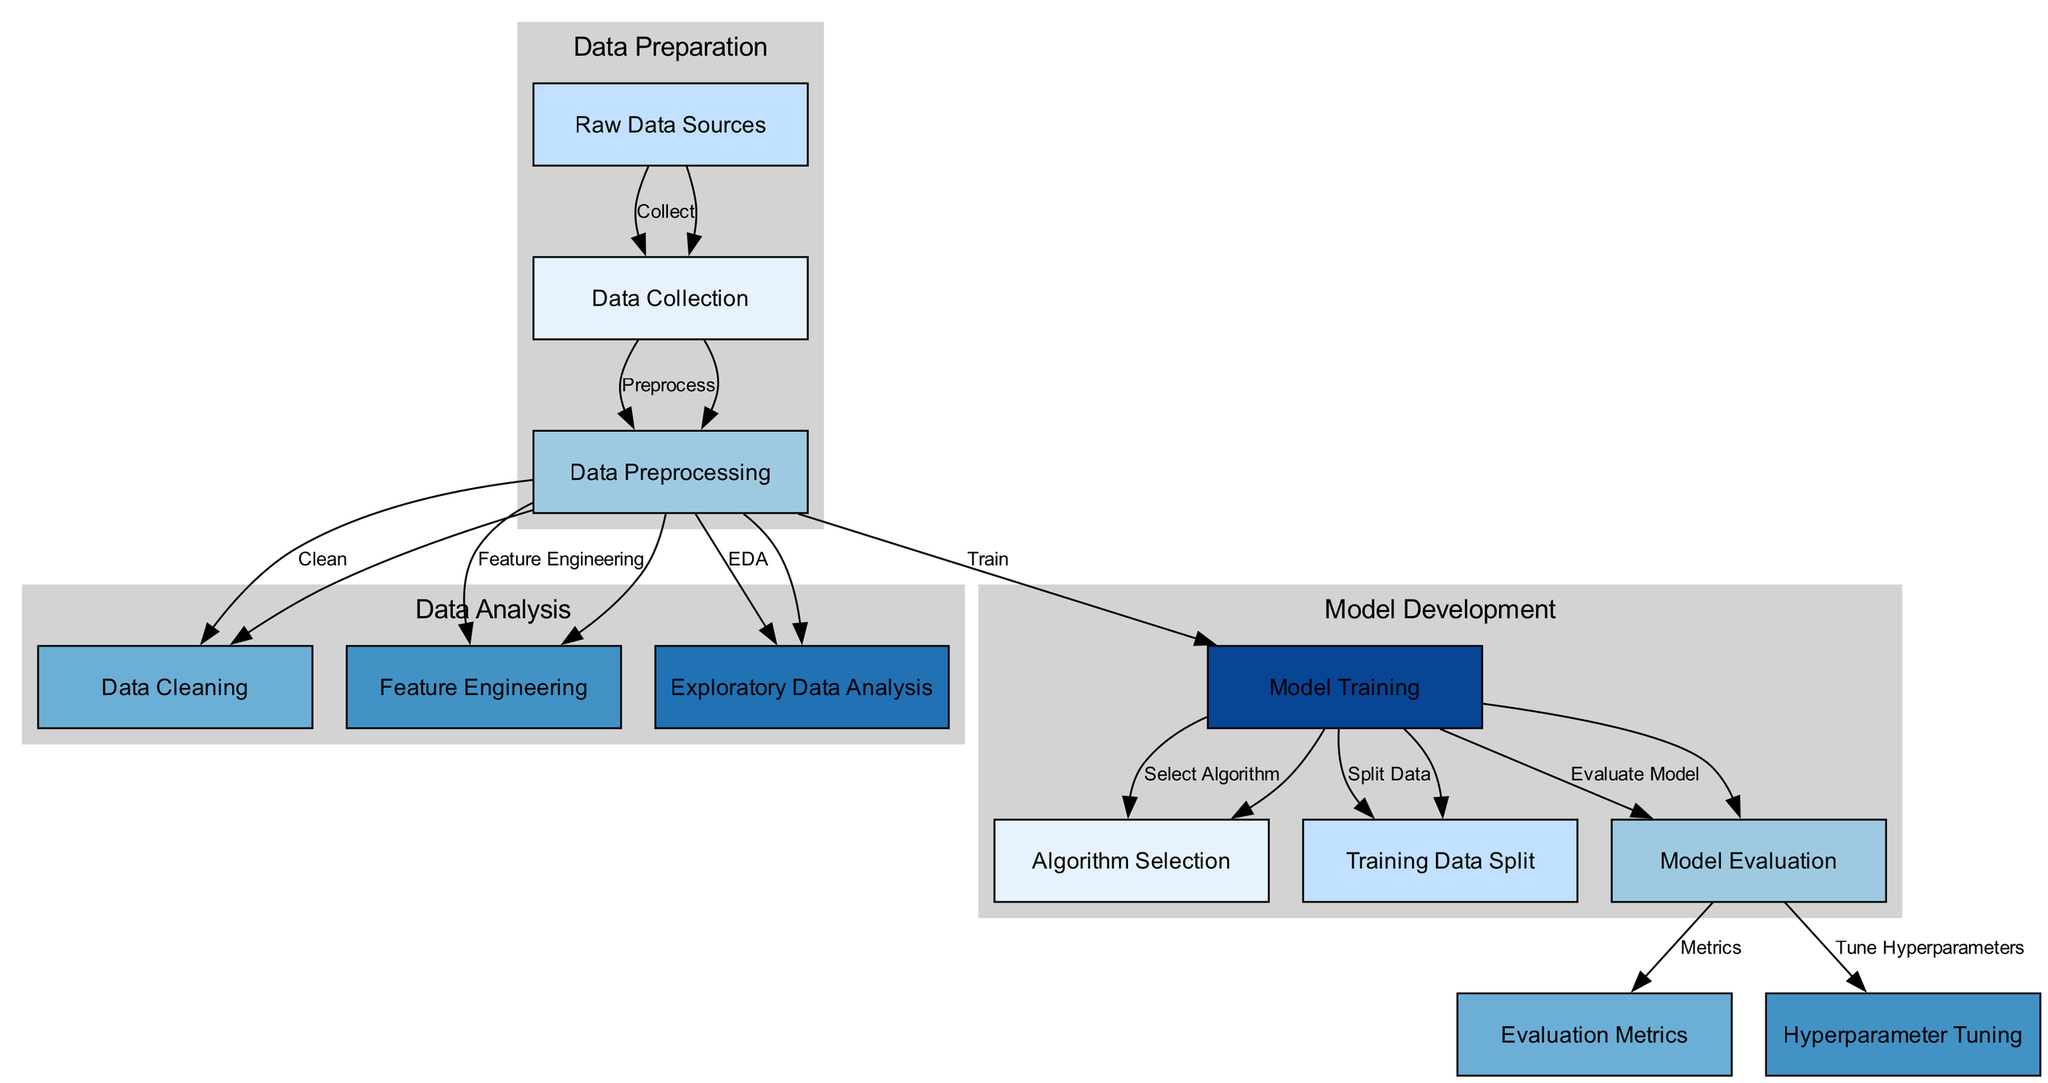What’s the first step in the machine learning model training process? The diagram shows 'Data Collection' as the first step in the process, indicating that it is the initial phase where data is gathered.
Answer: Data Collection How many nodes are there in the diagram? By counting each distinct step in the training process depicted in the diagram, we find there are a total of 12 nodes.
Answer: 12 What does the 'Data Cleaning' node represent? The 'Data Cleaning' node is a part of the data preprocessing stage, representing the operation of identifying and correcting errors in the dataset before further analysis.
Answer: Cleaning data Which node follows 'Model Training'? The diagram indicates that 'Model Evaluation' directly follows 'Model Training', showing that after training the model, the next step is to evaluate its performance.
Answer: Model Evaluation What are the two operations conducted after 'Data Preprocessing'? The diagram shows that after 'Data Preprocessing', the two operations are 'Data Cleaning' and 'Feature Engineering', both being essential processes in preparing data for modeling.
Answer: Data Cleaning and Feature Engineering How is 'Hyperparameter Tuning' related to 'Model Evaluation'? The diagram illustrates that 'Hyperparameter Tuning' is a step that occurs after 'Model Evaluation', indicating that it is a refinement process that may influence model assessment.
Answer: Tune Hyperparameters Which node is connected to 'Model Training' but does not lead to 'Model Evaluation'? The 'Algorithm Selection' node is connected to 'Model Training' as an action taken during the training phase and it does not lead to 'Model Evaluation'.
Answer: Algorithm Selection What do the edges represent in the context of the diagram? The edges in the diagram represent the progression and relationships between different steps in the machine learning model training process, indicating the flow of operations.
Answer: Relationships and flow How many distinct clusters are present in the diagram? The diagram has three distinct clusters: 'Data Preparation', 'Data Analysis', and 'Model Development', each grouping related nodes together.
Answer: Three clusters 